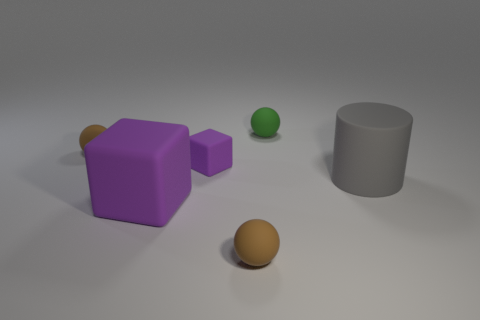What is the material of the purple block behind the big cylinder?
Offer a very short reply. Rubber. Is there anything else that is the same size as the green rubber sphere?
Give a very brief answer. Yes. There is a large gray object; are there any green balls in front of it?
Provide a short and direct response. No. What is the shape of the large gray matte object?
Make the answer very short. Cylinder. How many objects are either small brown matte balls that are behind the large gray cylinder or large rubber cubes?
Offer a very short reply. 2. What number of other things are there of the same color as the cylinder?
Keep it short and to the point. 0. There is a big cylinder; does it have the same color as the big object that is on the left side of the tiny green object?
Provide a short and direct response. No. Does the tiny green sphere have the same material as the brown sphere that is behind the cylinder?
Make the answer very short. Yes. The big matte block is what color?
Give a very brief answer. Purple. There is a big thing that is to the right of the tiny brown sphere that is on the right side of the small object to the left of the big purple rubber block; what is its color?
Ensure brevity in your answer.  Gray. 